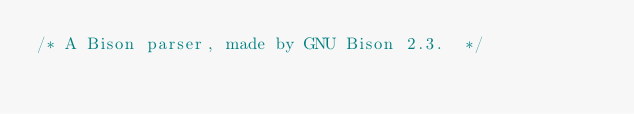Convert code to text. <code><loc_0><loc_0><loc_500><loc_500><_C_>/* A Bison parser, made by GNU Bison 2.3.  */
</code> 